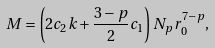<formula> <loc_0><loc_0><loc_500><loc_500>M = \left ( 2 c _ { 2 } k + \frac { 3 - p } { 2 } c _ { 1 } \right ) N _ { p } r _ { 0 } ^ { 7 - p } ,</formula> 